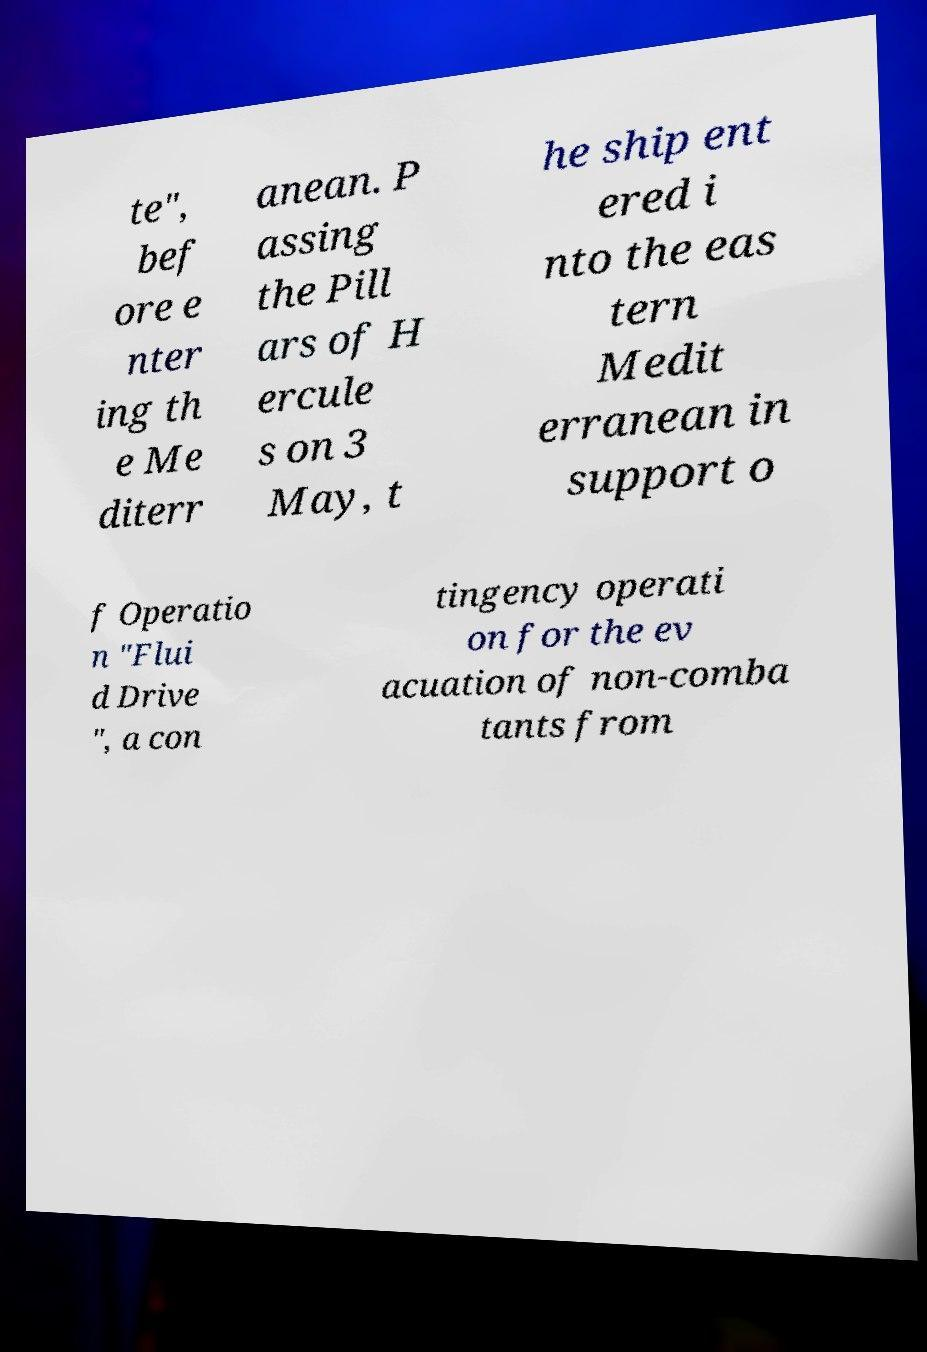Can you accurately transcribe the text from the provided image for me? te", bef ore e nter ing th e Me diterr anean. P assing the Pill ars of H ercule s on 3 May, t he ship ent ered i nto the eas tern Medit erranean in support o f Operatio n "Flui d Drive ", a con tingency operati on for the ev acuation of non-comba tants from 